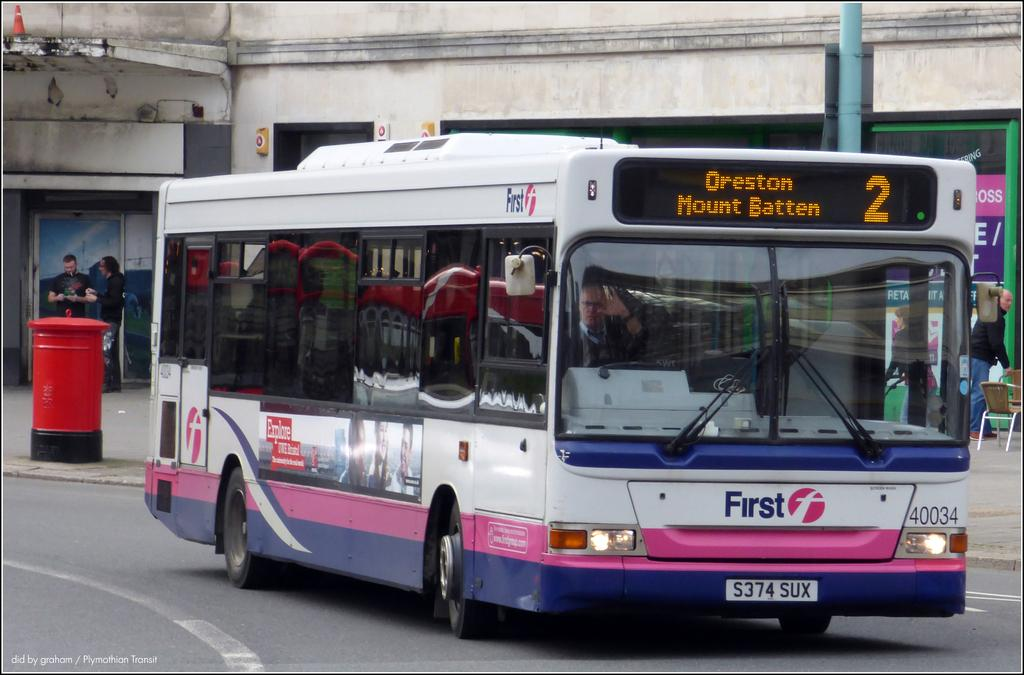<image>
Give a short and clear explanation of the subsequent image. A No. 2 bus is heading to Oreston and Mount Batten. 